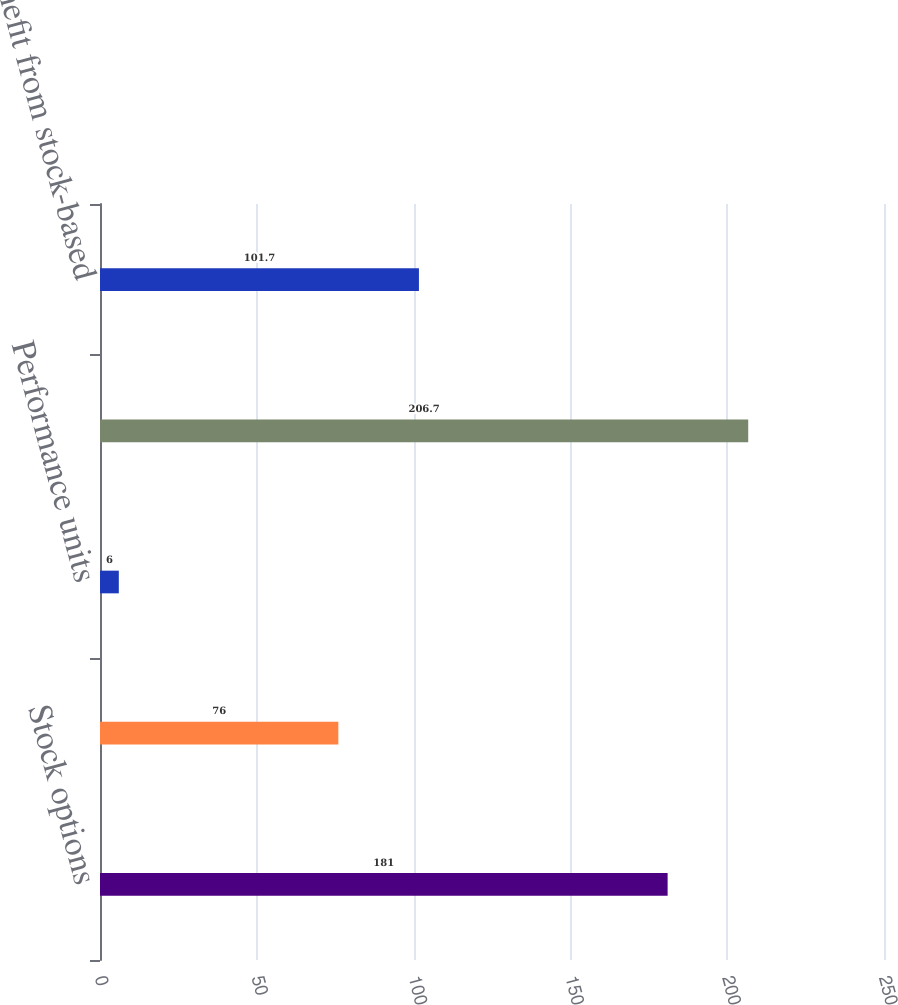Convert chart to OTSL. <chart><loc_0><loc_0><loc_500><loc_500><bar_chart><fcel>Stock options<fcel>Restricted stock<fcel>Performance units<fcel>Total stock-based compensation<fcel>Tax benefit from stock-based<nl><fcel>181<fcel>76<fcel>6<fcel>206.7<fcel>101.7<nl></chart> 